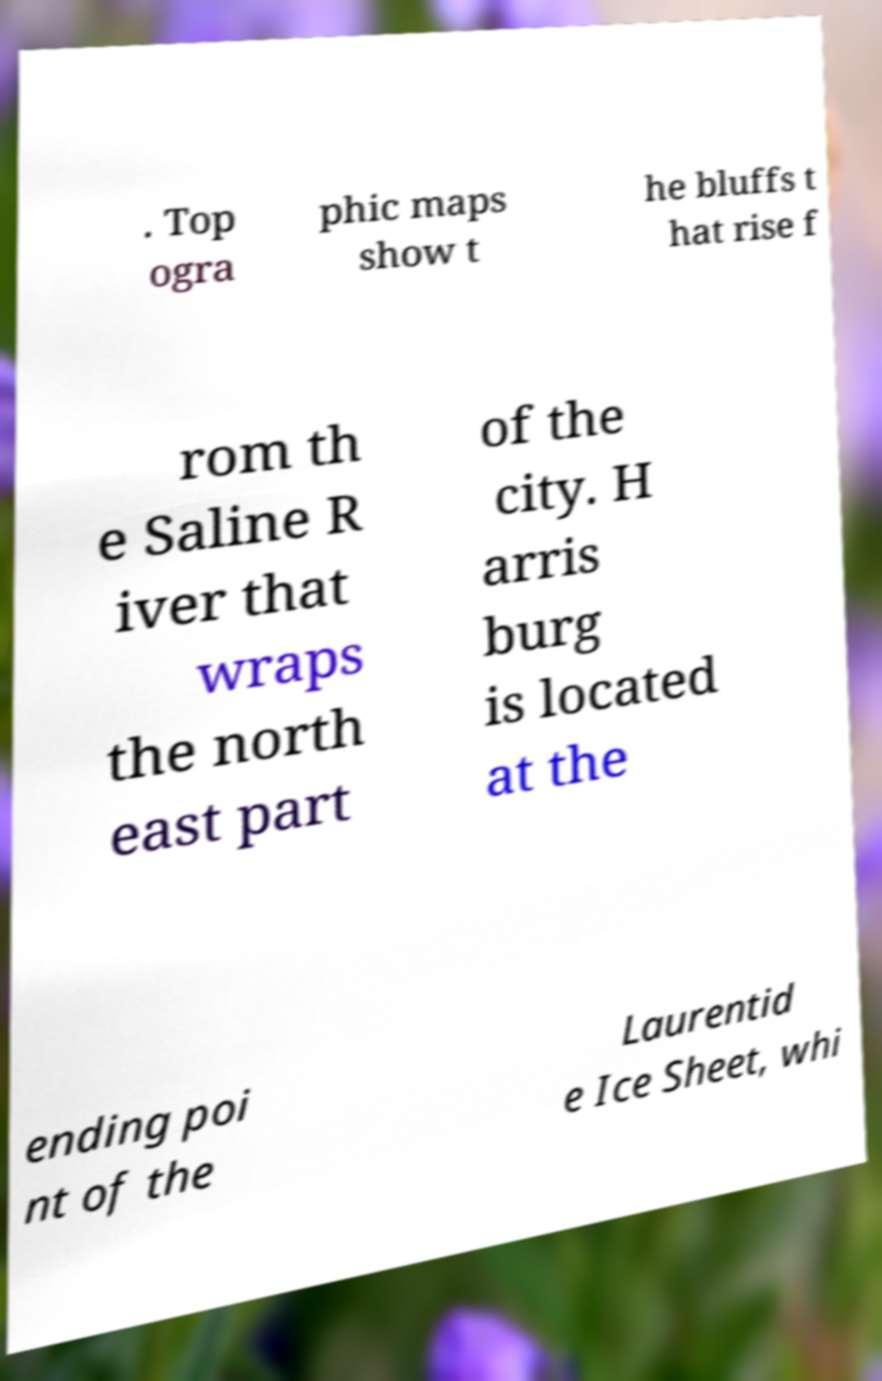There's text embedded in this image that I need extracted. Can you transcribe it verbatim? . Top ogra phic maps show t he bluffs t hat rise f rom th e Saline R iver that wraps the north east part of the city. H arris burg is located at the ending poi nt of the Laurentid e Ice Sheet, whi 